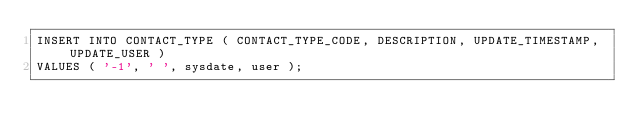Convert code to text. <code><loc_0><loc_0><loc_500><loc_500><_SQL_>INSERT INTO CONTACT_TYPE ( CONTACT_TYPE_CODE, DESCRIPTION, UPDATE_TIMESTAMP, UPDATE_USER ) 
VALUES ( '-1', ' ', sysdate, user );</code> 